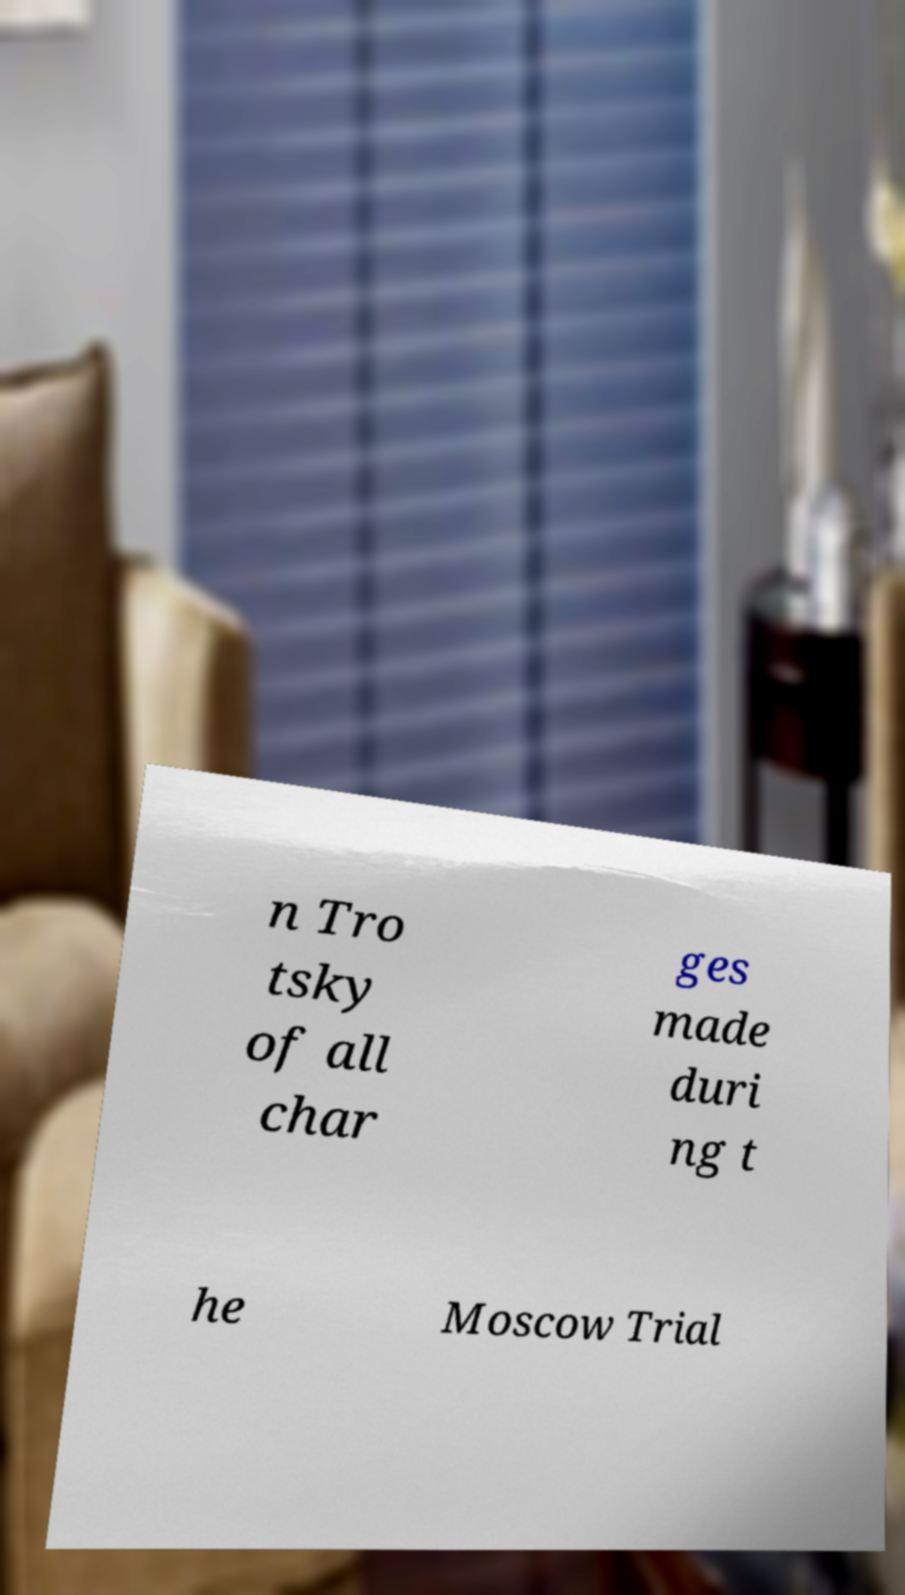There's text embedded in this image that I need extracted. Can you transcribe it verbatim? n Tro tsky of all char ges made duri ng t he Moscow Trial 